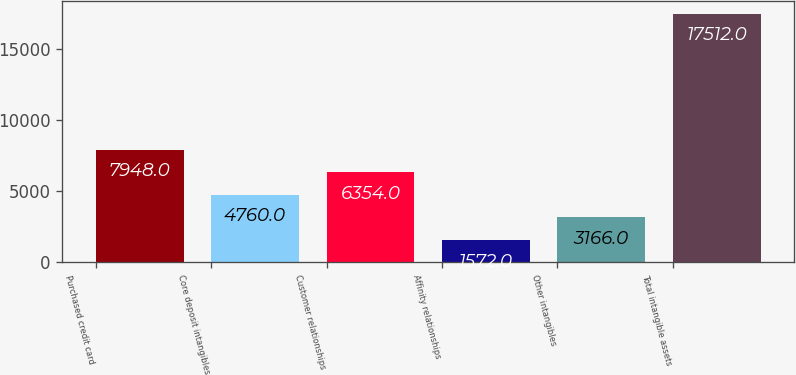<chart> <loc_0><loc_0><loc_500><loc_500><bar_chart><fcel>Purchased credit card<fcel>Core deposit intangibles<fcel>Customer relationships<fcel>Affinity relationships<fcel>Other intangibles<fcel>Total intangible assets<nl><fcel>7948<fcel>4760<fcel>6354<fcel>1572<fcel>3166<fcel>17512<nl></chart> 